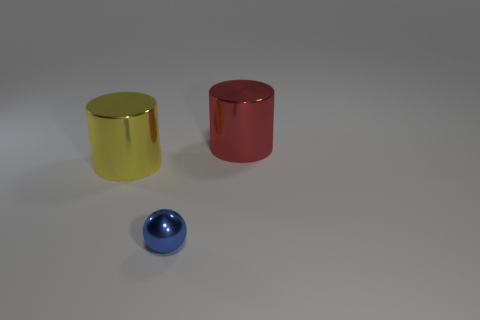Add 3 big yellow objects. How many objects exist? 6 Subtract all cylinders. How many objects are left? 1 Subtract all brown matte cylinders. Subtract all balls. How many objects are left? 2 Add 2 yellow metal objects. How many yellow metal objects are left? 3 Add 3 rubber objects. How many rubber objects exist? 3 Subtract 0 purple cylinders. How many objects are left? 3 